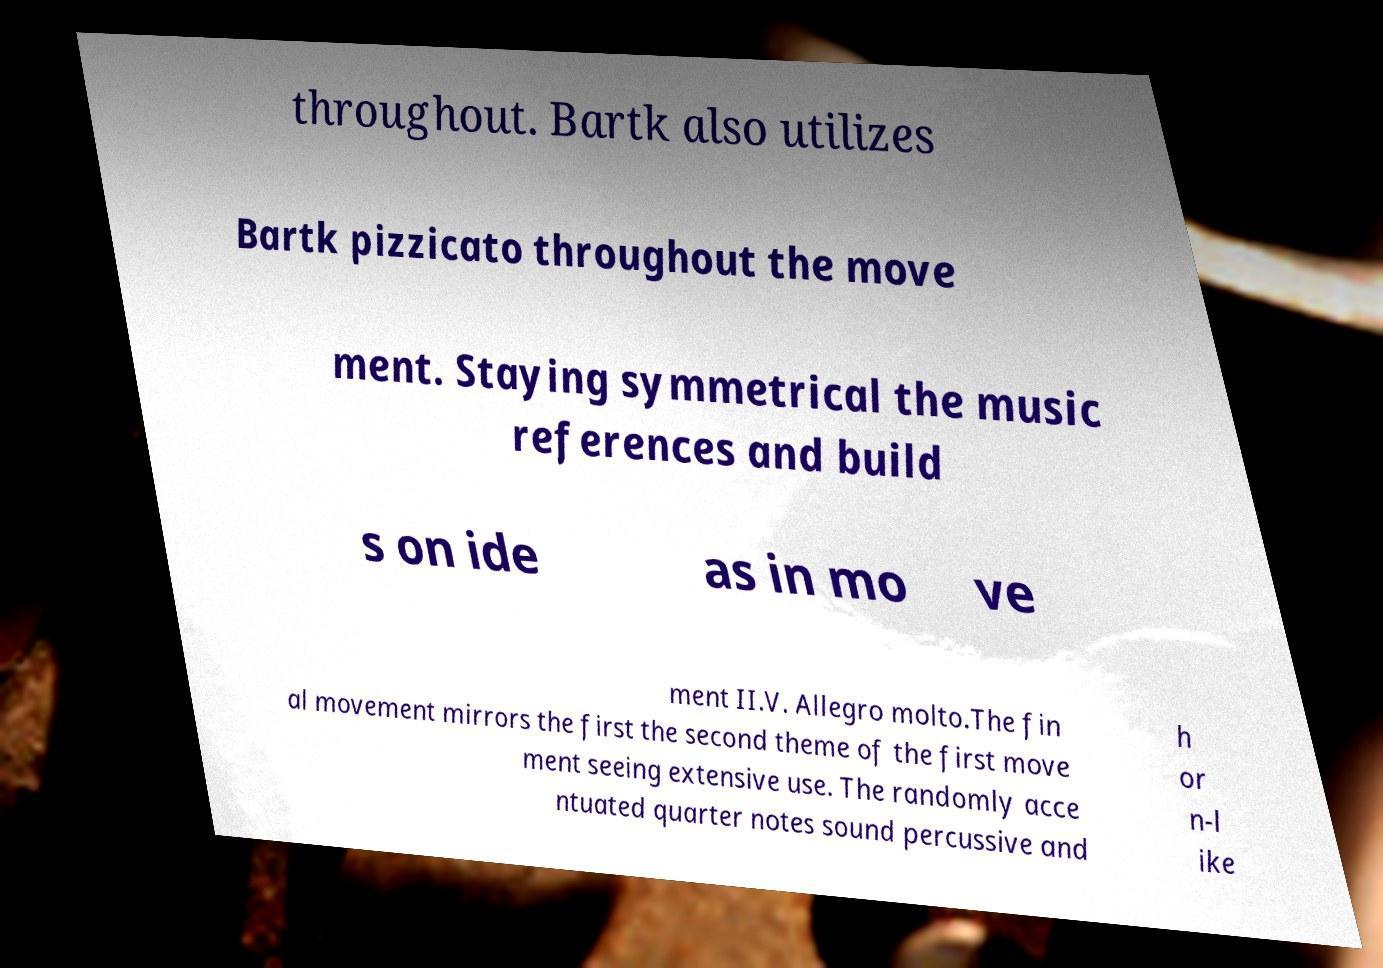For documentation purposes, I need the text within this image transcribed. Could you provide that? throughout. Bartk also utilizes Bartk pizzicato throughout the move ment. Staying symmetrical the music references and build s on ide as in mo ve ment II.V. Allegro molto.The fin al movement mirrors the first the second theme of the first move ment seeing extensive use. The randomly acce ntuated quarter notes sound percussive and h or n-l ike 